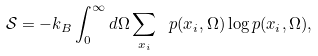Convert formula to latex. <formula><loc_0><loc_0><loc_500><loc_500>\mathcal { S } = - k _ { B } \int _ { 0 } ^ { \infty } d \Omega \sum _ { x _ { i } } \ p ( x _ { i } , \Omega ) \log p ( x _ { i } , \Omega ) ,</formula> 